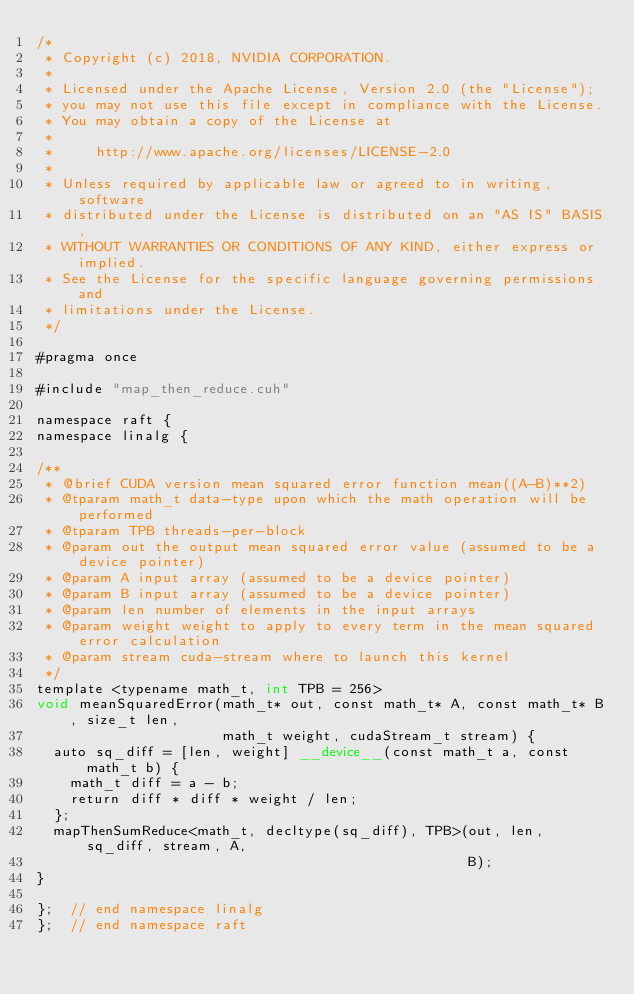<code> <loc_0><loc_0><loc_500><loc_500><_Cuda_>/*
 * Copyright (c) 2018, NVIDIA CORPORATION.
 *
 * Licensed under the Apache License, Version 2.0 (the "License");
 * you may not use this file except in compliance with the License.
 * You may obtain a copy of the License at
 *
 *     http://www.apache.org/licenses/LICENSE-2.0
 *
 * Unless required by applicable law or agreed to in writing, software
 * distributed under the License is distributed on an "AS IS" BASIS,
 * WITHOUT WARRANTIES OR CONDITIONS OF ANY KIND, either express or implied.
 * See the License for the specific language governing permissions and
 * limitations under the License.
 */

#pragma once

#include "map_then_reduce.cuh"

namespace raft {
namespace linalg {

/**
 * @brief CUDA version mean squared error function mean((A-B)**2)
 * @tparam math_t data-type upon which the math operation will be performed
 * @tparam TPB threads-per-block 
 * @param out the output mean squared error value (assumed to be a device pointer)
 * @param A input array (assumed to be a device pointer)
 * @param B input array (assumed to be a device pointer)
 * @param len number of elements in the input arrays
 * @param weight weight to apply to every term in the mean squared error calculation
 * @param stream cuda-stream where to launch this kernel
 */
template <typename math_t, int TPB = 256>
void meanSquaredError(math_t* out, const math_t* A, const math_t* B, size_t len,
                      math_t weight, cudaStream_t stream) {
  auto sq_diff = [len, weight] __device__(const math_t a, const math_t b) {
    math_t diff = a - b;
    return diff * diff * weight / len;
  };
  mapThenSumReduce<math_t, decltype(sq_diff), TPB>(out, len, sq_diff, stream, A,
                                                   B);
}

};  // end namespace linalg
};  // end namespace raft
</code> 